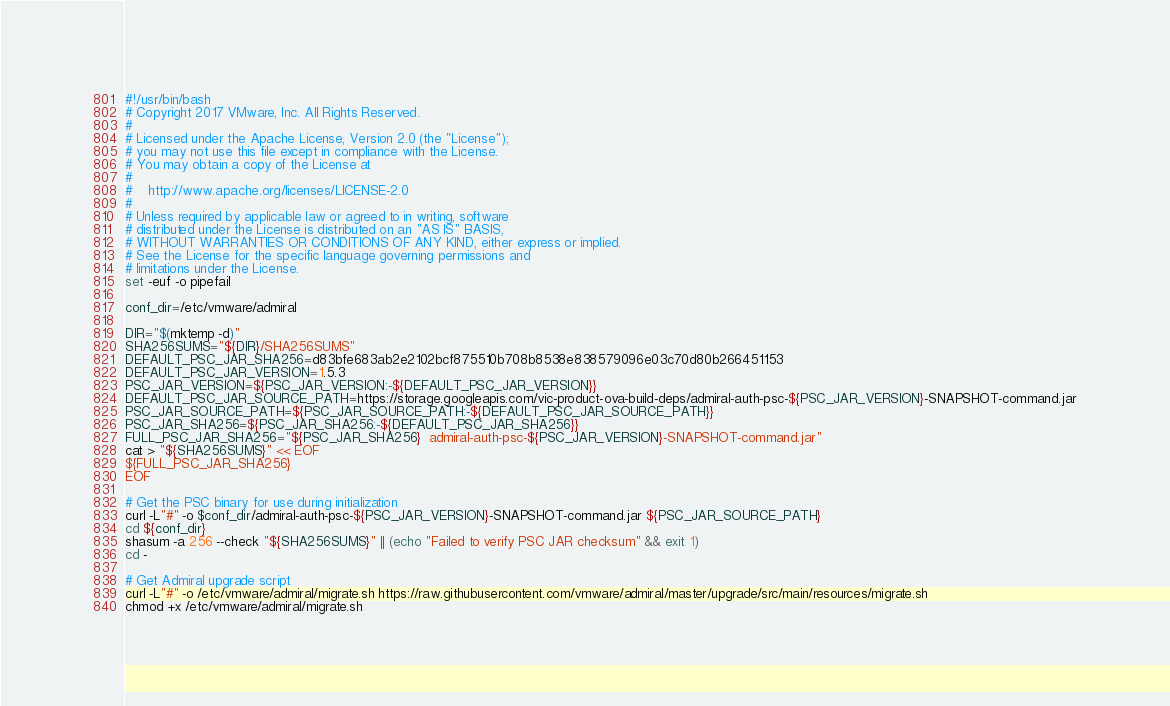Convert code to text. <code><loc_0><loc_0><loc_500><loc_500><_Bash_>#!/usr/bin/bash
# Copyright 2017 VMware, Inc. All Rights Reserved.
#
# Licensed under the Apache License, Version 2.0 (the "License");
# you may not use this file except in compliance with the License.
# You may obtain a copy of the License at
#
#    http://www.apache.org/licenses/LICENSE-2.0
#
# Unless required by applicable law or agreed to in writing, software
# distributed under the License is distributed on an "AS IS" BASIS,
# WITHOUT WARRANTIES OR CONDITIONS OF ANY KIND, either express or implied.
# See the License for the specific language governing permissions and
# limitations under the License.
set -euf -o pipefail

conf_dir=/etc/vmware/admiral

DIR="$(mktemp -d)"
SHA256SUMS="${DIR}/SHA256SUMS"
DEFAULT_PSC_JAR_SHA256=d83bfe683ab2e2102bcf875510b708b8538e838579096e03c70d80b266451153
DEFAULT_PSC_JAR_VERSION=1.5.3
PSC_JAR_VERSION=${PSC_JAR_VERSION:-${DEFAULT_PSC_JAR_VERSION}}
DEFAULT_PSC_JAR_SOURCE_PATH=https://storage.googleapis.com/vic-product-ova-build-deps/admiral-auth-psc-${PSC_JAR_VERSION}-SNAPSHOT-command.jar
PSC_JAR_SOURCE_PATH=${PSC_JAR_SOURCE_PATH:-${DEFAULT_PSC_JAR_SOURCE_PATH}}
PSC_JAR_SHA256=${PSC_JAR_SHA256:-${DEFAULT_PSC_JAR_SHA256}}
FULL_PSC_JAR_SHA256="${PSC_JAR_SHA256}  admiral-auth-psc-${PSC_JAR_VERSION}-SNAPSHOT-command.jar"
cat > "${SHA256SUMS}" << EOF
${FULL_PSC_JAR_SHA256}
EOF

# Get the PSC binary for use during initialization
curl -L"#" -o $conf_dir/admiral-auth-psc-${PSC_JAR_VERSION}-SNAPSHOT-command.jar ${PSC_JAR_SOURCE_PATH}
cd ${conf_dir}
shasum -a 256 --check "${SHA256SUMS}" || (echo "Failed to verify PSC JAR checksum" && exit 1)
cd -

# Get Admiral upgrade script
curl -L"#" -o /etc/vmware/admiral/migrate.sh https://raw.githubusercontent.com/vmware/admiral/master/upgrade/src/main/resources/migrate.sh
chmod +x /etc/vmware/admiral/migrate.sh
</code> 